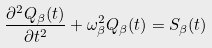<formula> <loc_0><loc_0><loc_500><loc_500>\frac { \partial ^ { 2 } Q _ { \beta } ( t ) } { \partial t ^ { 2 } } + \omega ^ { 2 } _ { \beta } Q _ { \beta } ( t ) = S _ { \beta } ( t )</formula> 